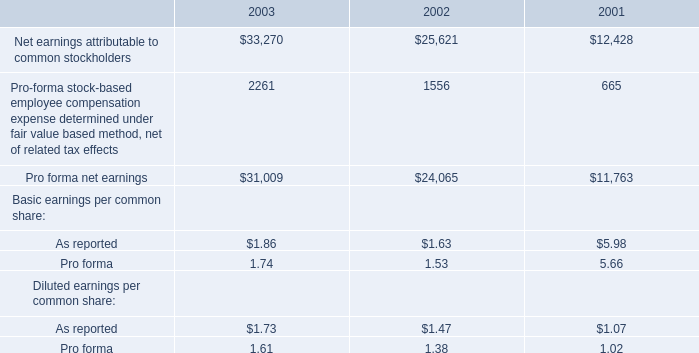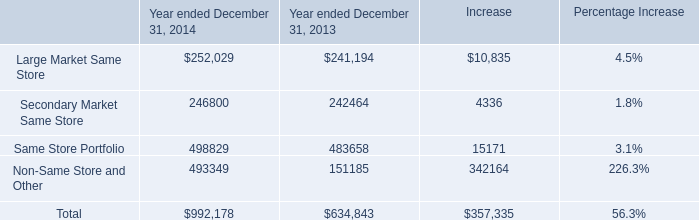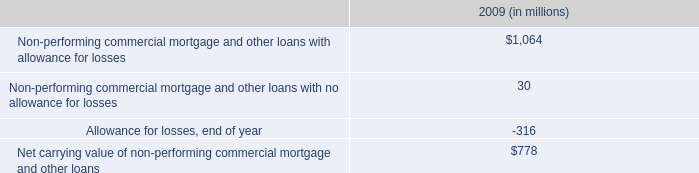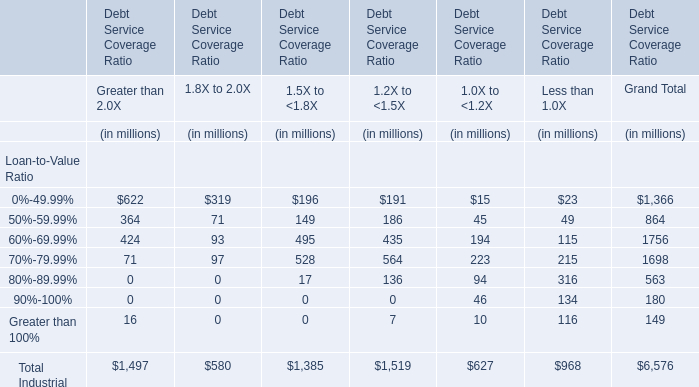What was the average of 70%-79.99% for 1.5X to <1.8X,1.2X to <1.5X, and 1.0X to <1.2X ? (in million) 
Computations: (((528 + 564) + 223) / 3)
Answer: 438.33333. 